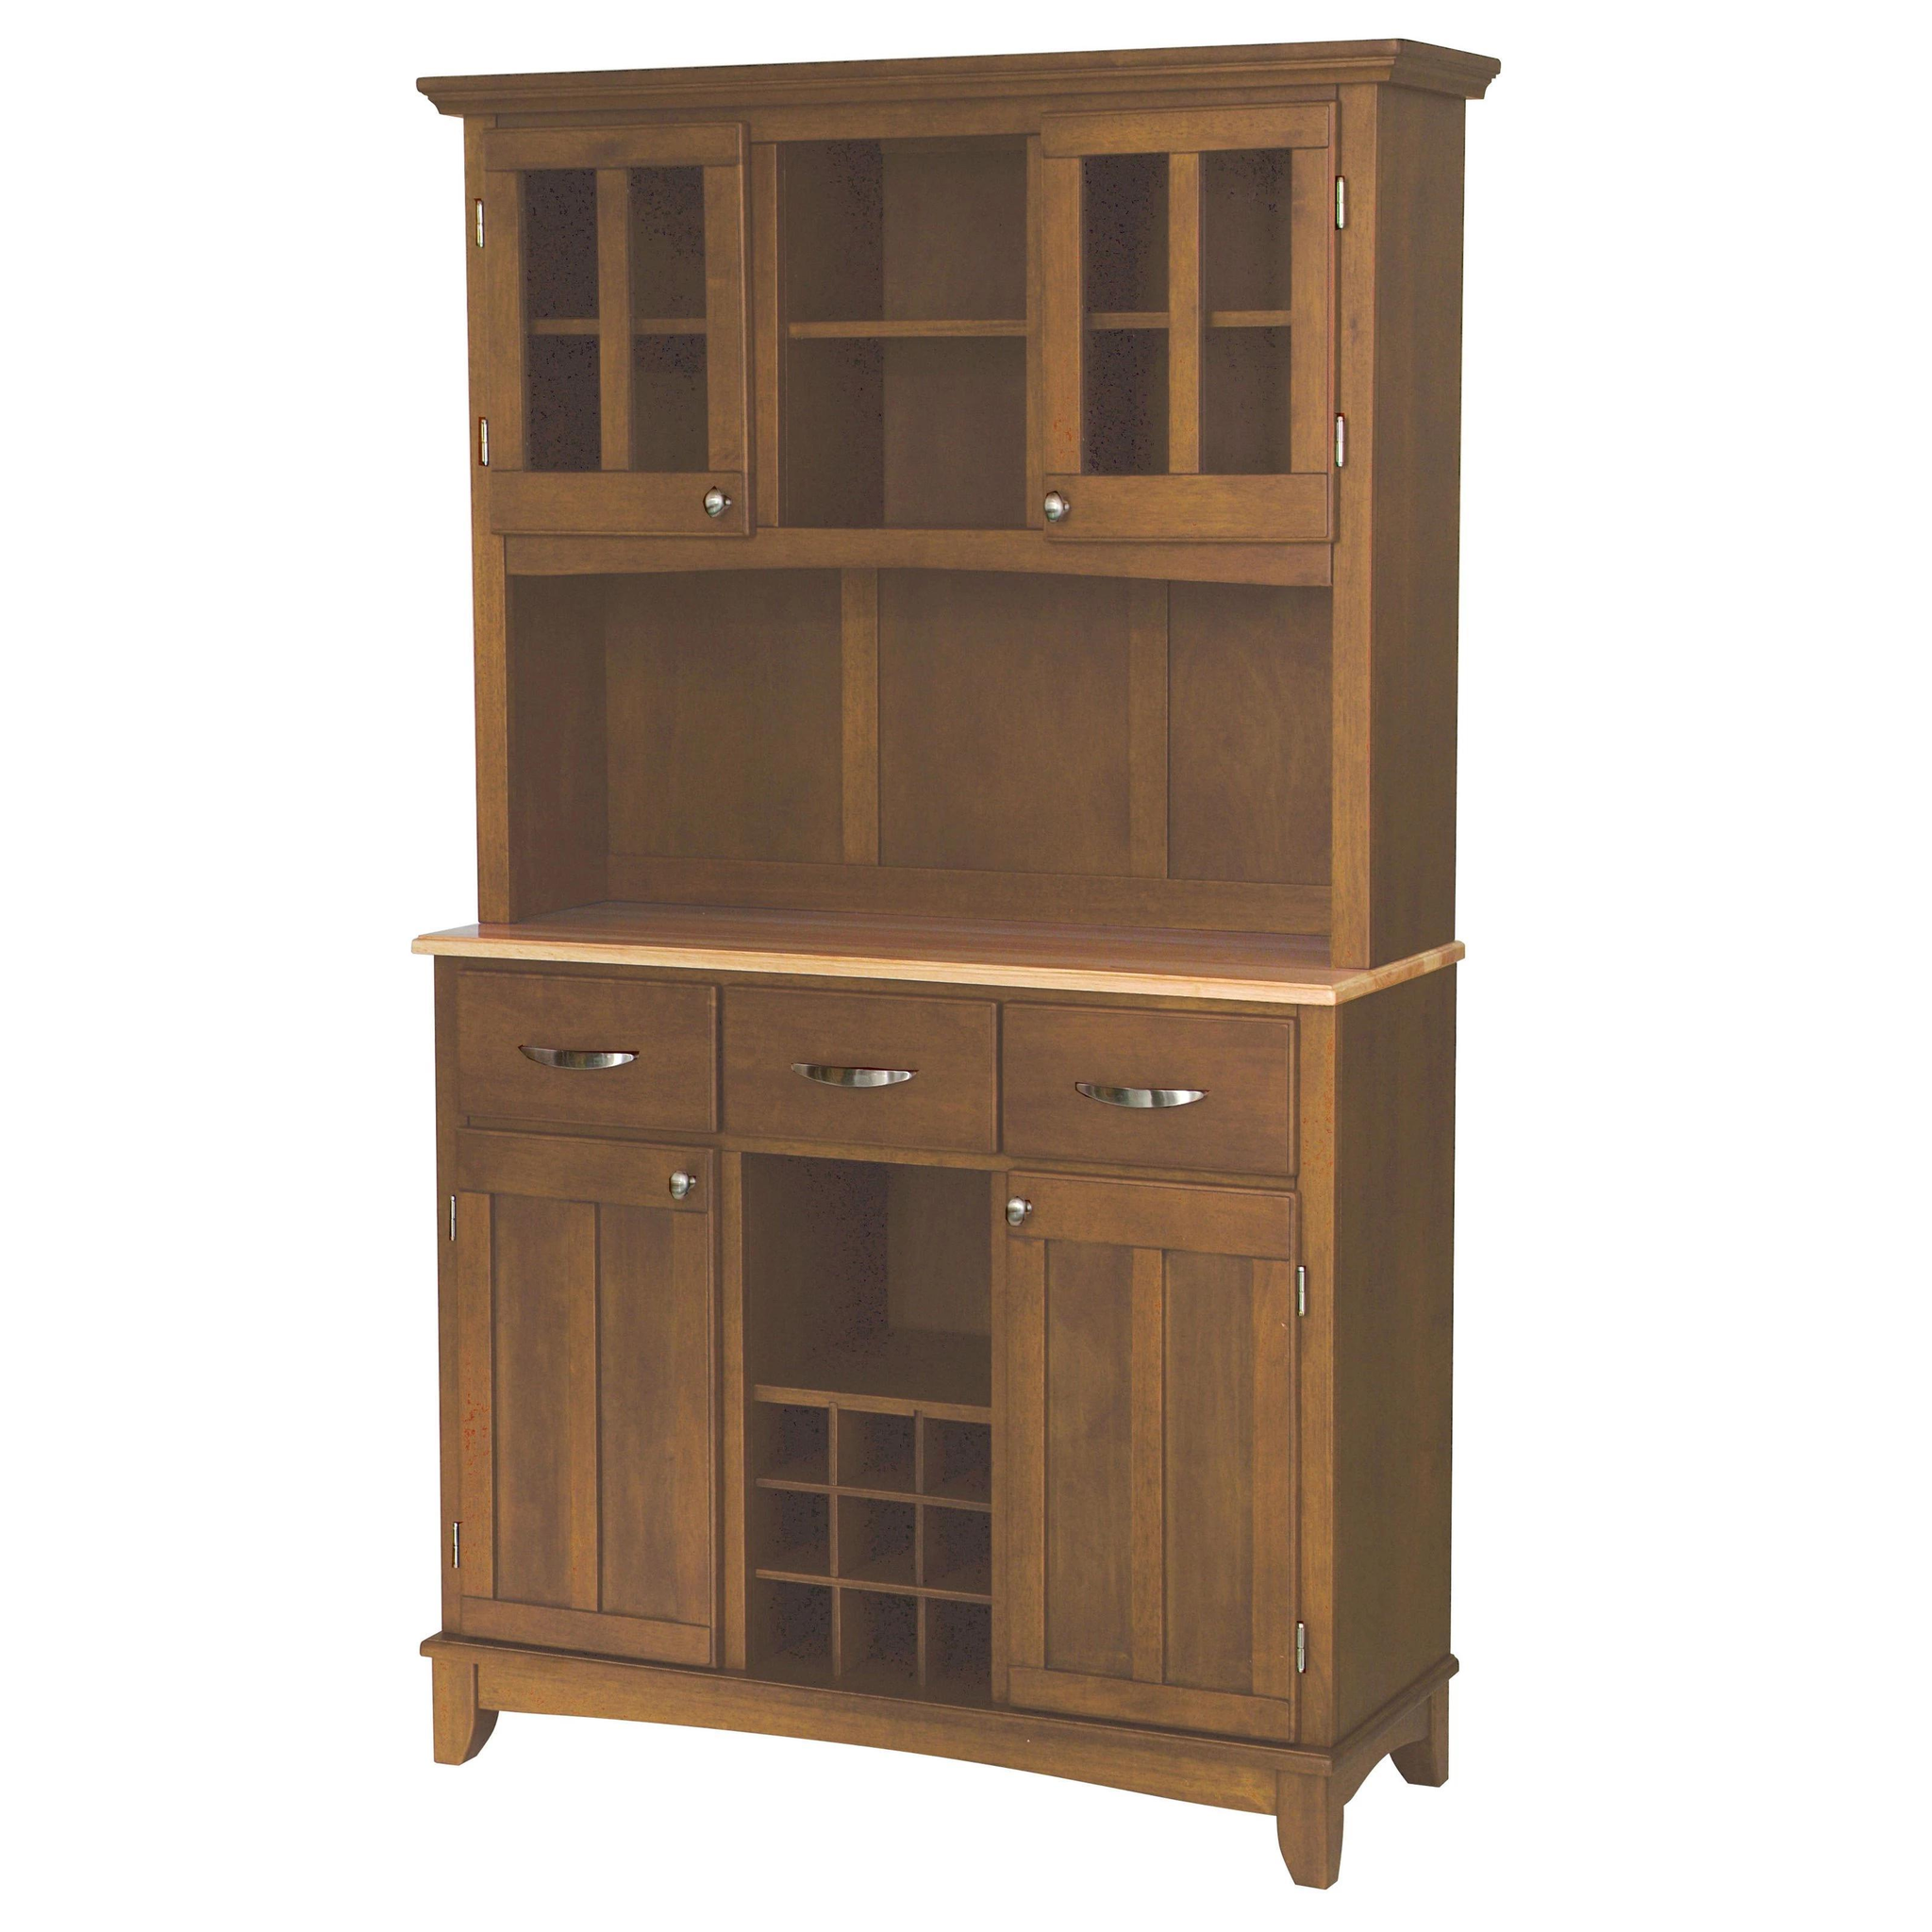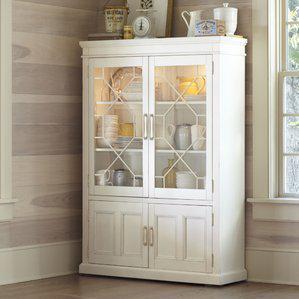The first image is the image on the left, the second image is the image on the right. Evaluate the accuracy of this statement regarding the images: "A brown wooden hutch has a flat top that extends beyond the cabinet, sits on short legs, and has been repurposed in the center bottom section to make a wine rack.". Is it true? Answer yes or no. Yes. The first image is the image on the left, the second image is the image on the right. Evaluate the accuracy of this statement regarding the images: "The right image contains a white china cabinet with glass doors.". Is it true? Answer yes or no. Yes. The first image is the image on the left, the second image is the image on the right. Assess this claim about the two images: "In one image there is a single white Kitchen storage unit  that holds white bowls and cups.". Correct or not? Answer yes or no. Yes. The first image is the image on the left, the second image is the image on the right. For the images displayed, is the sentence "The image on the right  contains a white wooden cabinet." factually correct? Answer yes or no. Yes. 